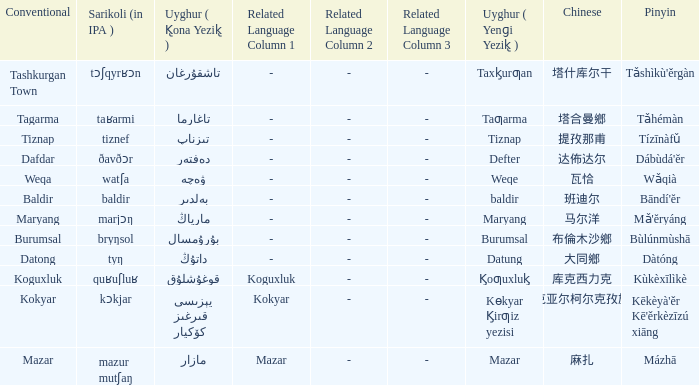Name the pinyin for تىزناپ Tízīnàfǔ. 